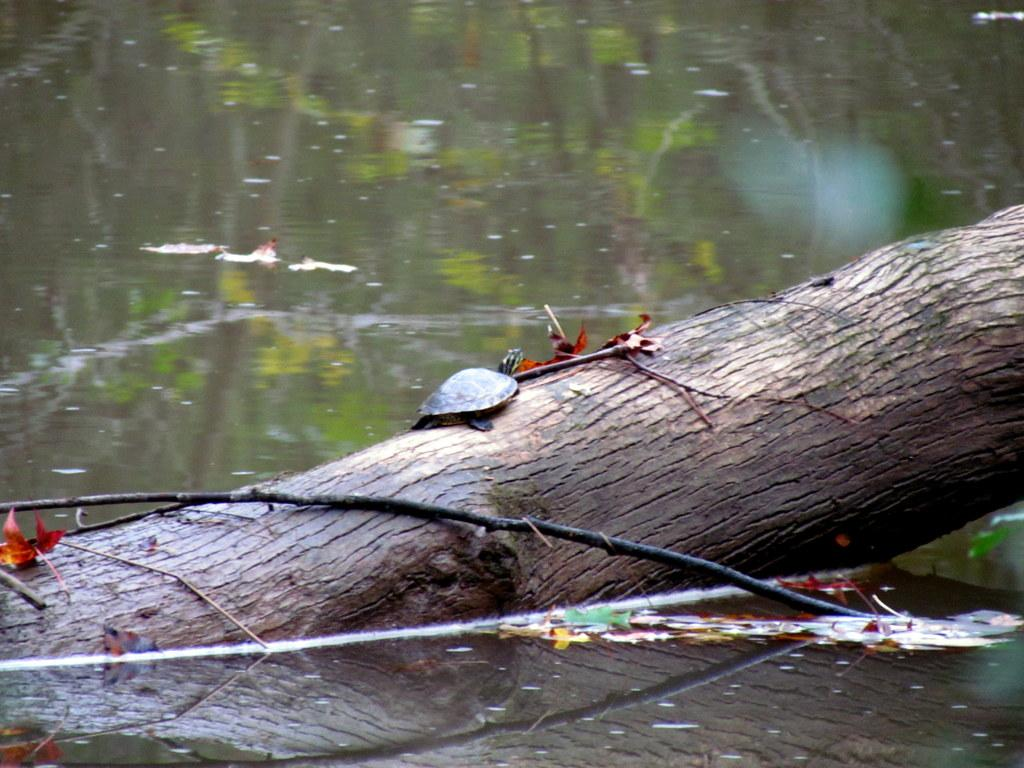What type of object can be seen partially submerged in the water in the image? There is a wooden log and a stick partially in the water in the image. What else can be seen floating on the water in the image? There are leaves on the water in the image. What type of tool is being used to attack the wooden log in the image? There is no tool or attack happening in the image; it simply shows a wooden log and a stick partially submerged in water with leaves floating on the surface. 